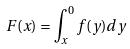<formula> <loc_0><loc_0><loc_500><loc_500>F ( x ) = \int _ { x } ^ { 0 } f ( y ) d y</formula> 